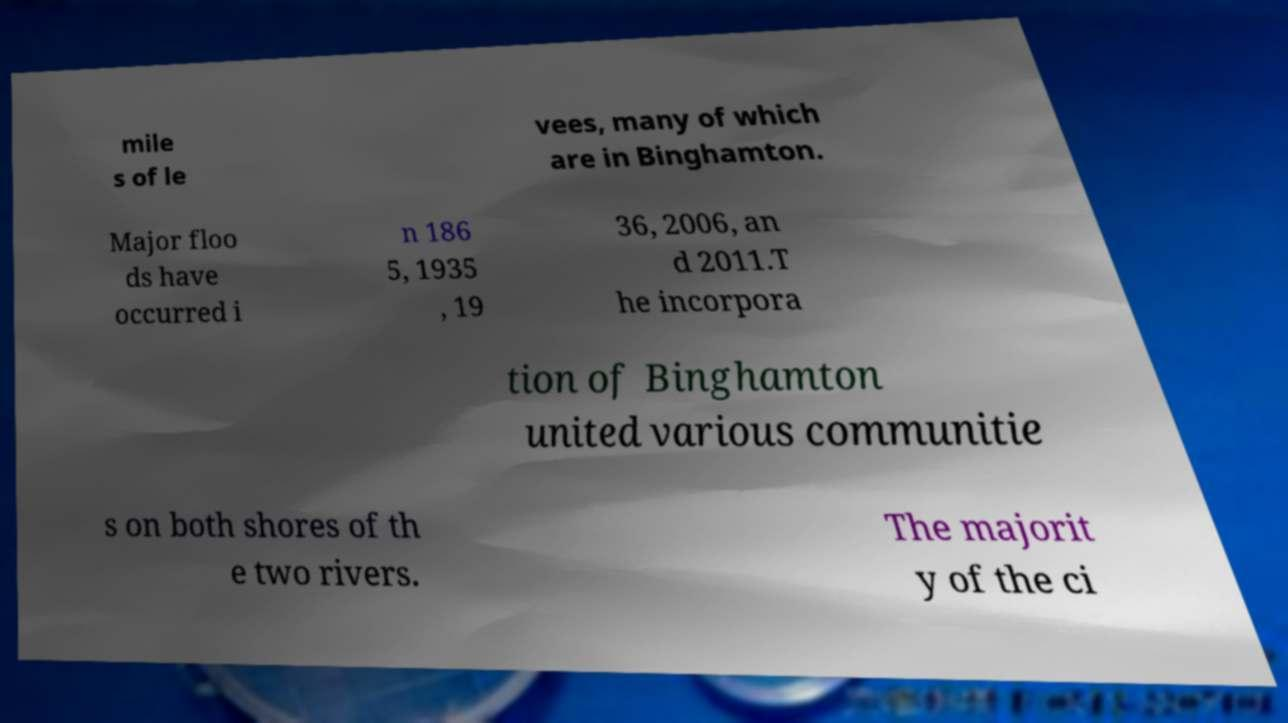Can you read and provide the text displayed in the image?This photo seems to have some interesting text. Can you extract and type it out for me? mile s of le vees, many of which are in Binghamton. Major floo ds have occurred i n 186 5, 1935 , 19 36, 2006, an d 2011.T he incorpora tion of Binghamton united various communitie s on both shores of th e two rivers. The majorit y of the ci 